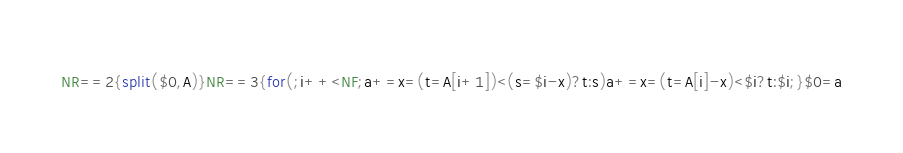<code> <loc_0><loc_0><loc_500><loc_500><_Awk_>NR==2{split($0,A)}NR==3{for(;i++<NF;a+=x=(t=A[i+1])<(s=$i-x)?t:s)a+=x=(t=A[i]-x)<$i?t:$i;}$0=a</code> 